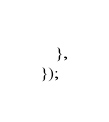Convert code to text. <code><loc_0><loc_0><loc_500><loc_500><_TypeScript_>	},
});
</code> 